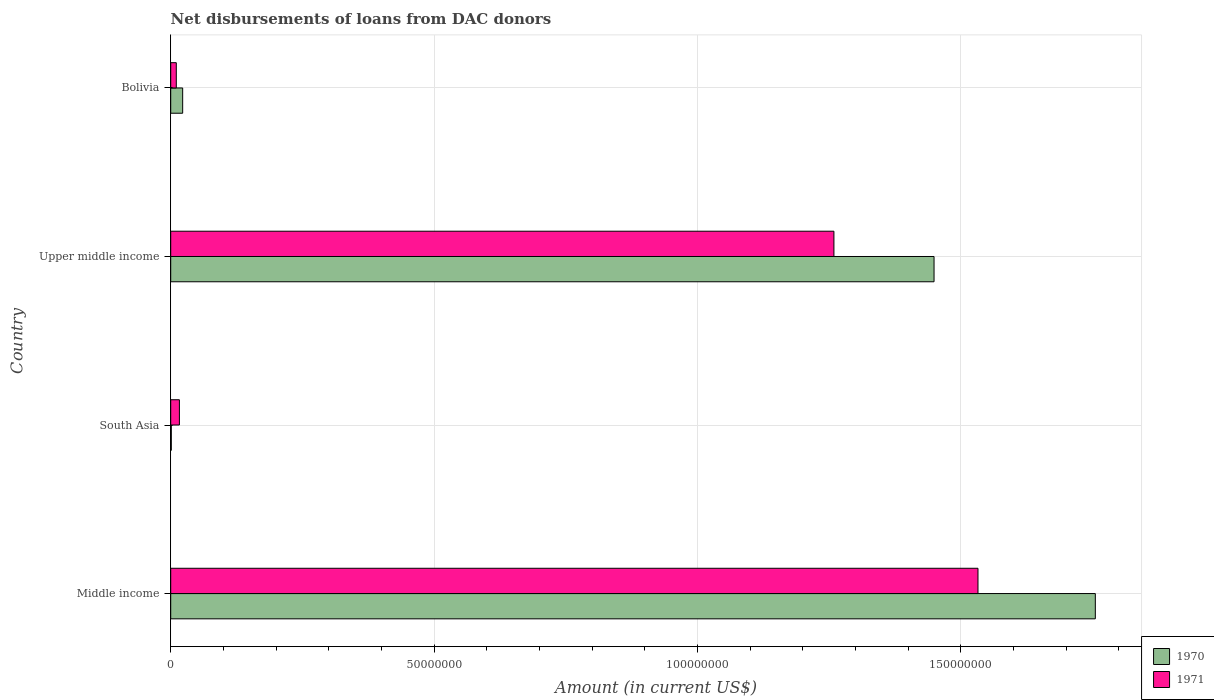How many different coloured bars are there?
Your response must be concise. 2. Are the number of bars per tick equal to the number of legend labels?
Your response must be concise. Yes. Are the number of bars on each tick of the Y-axis equal?
Your answer should be very brief. Yes. What is the label of the 1st group of bars from the top?
Ensure brevity in your answer.  Bolivia. What is the amount of loans disbursed in 1970 in South Asia?
Your answer should be compact. 1.09e+05. Across all countries, what is the maximum amount of loans disbursed in 1970?
Your answer should be compact. 1.76e+08. Across all countries, what is the minimum amount of loans disbursed in 1971?
Give a very brief answer. 1.06e+06. In which country was the amount of loans disbursed in 1971 minimum?
Make the answer very short. Bolivia. What is the total amount of loans disbursed in 1970 in the graph?
Your answer should be compact. 3.23e+08. What is the difference between the amount of loans disbursed in 1970 in Middle income and that in Upper middle income?
Your answer should be compact. 3.06e+07. What is the difference between the amount of loans disbursed in 1971 in South Asia and the amount of loans disbursed in 1970 in Bolivia?
Make the answer very short. -6.20e+05. What is the average amount of loans disbursed in 1971 per country?
Make the answer very short. 7.05e+07. What is the difference between the amount of loans disbursed in 1971 and amount of loans disbursed in 1970 in South Asia?
Give a very brief answer. 1.54e+06. In how many countries, is the amount of loans disbursed in 1971 greater than 130000000 US$?
Give a very brief answer. 1. What is the ratio of the amount of loans disbursed in 1971 in Middle income to that in South Asia?
Offer a terse response. 92.89. What is the difference between the highest and the second highest amount of loans disbursed in 1971?
Make the answer very short. 2.74e+07. What is the difference between the highest and the lowest amount of loans disbursed in 1970?
Your answer should be compact. 1.75e+08. In how many countries, is the amount of loans disbursed in 1971 greater than the average amount of loans disbursed in 1971 taken over all countries?
Your answer should be very brief. 2. Are all the bars in the graph horizontal?
Make the answer very short. Yes. Are the values on the major ticks of X-axis written in scientific E-notation?
Ensure brevity in your answer.  No. Does the graph contain any zero values?
Provide a short and direct response. No. Where does the legend appear in the graph?
Your answer should be compact. Bottom right. What is the title of the graph?
Make the answer very short. Net disbursements of loans from DAC donors. What is the label or title of the X-axis?
Provide a succinct answer. Amount (in current US$). What is the Amount (in current US$) of 1970 in Middle income?
Your answer should be compact. 1.76e+08. What is the Amount (in current US$) of 1971 in Middle income?
Your response must be concise. 1.53e+08. What is the Amount (in current US$) in 1970 in South Asia?
Your response must be concise. 1.09e+05. What is the Amount (in current US$) in 1971 in South Asia?
Provide a succinct answer. 1.65e+06. What is the Amount (in current US$) in 1970 in Upper middle income?
Make the answer very short. 1.45e+08. What is the Amount (in current US$) of 1971 in Upper middle income?
Provide a succinct answer. 1.26e+08. What is the Amount (in current US$) in 1970 in Bolivia?
Give a very brief answer. 2.27e+06. What is the Amount (in current US$) in 1971 in Bolivia?
Your answer should be very brief. 1.06e+06. Across all countries, what is the maximum Amount (in current US$) of 1970?
Offer a terse response. 1.76e+08. Across all countries, what is the maximum Amount (in current US$) of 1971?
Provide a succinct answer. 1.53e+08. Across all countries, what is the minimum Amount (in current US$) in 1970?
Ensure brevity in your answer.  1.09e+05. Across all countries, what is the minimum Amount (in current US$) of 1971?
Provide a short and direct response. 1.06e+06. What is the total Amount (in current US$) in 1970 in the graph?
Give a very brief answer. 3.23e+08. What is the total Amount (in current US$) of 1971 in the graph?
Make the answer very short. 2.82e+08. What is the difference between the Amount (in current US$) in 1970 in Middle income and that in South Asia?
Give a very brief answer. 1.75e+08. What is the difference between the Amount (in current US$) in 1971 in Middle income and that in South Asia?
Your answer should be compact. 1.52e+08. What is the difference between the Amount (in current US$) in 1970 in Middle income and that in Upper middle income?
Provide a succinct answer. 3.06e+07. What is the difference between the Amount (in current US$) of 1971 in Middle income and that in Upper middle income?
Keep it short and to the point. 2.74e+07. What is the difference between the Amount (in current US$) in 1970 in Middle income and that in Bolivia?
Offer a very short reply. 1.73e+08. What is the difference between the Amount (in current US$) of 1971 in Middle income and that in Bolivia?
Your answer should be compact. 1.52e+08. What is the difference between the Amount (in current US$) of 1970 in South Asia and that in Upper middle income?
Your answer should be very brief. -1.45e+08. What is the difference between the Amount (in current US$) of 1971 in South Asia and that in Upper middle income?
Provide a succinct answer. -1.24e+08. What is the difference between the Amount (in current US$) in 1970 in South Asia and that in Bolivia?
Provide a short and direct response. -2.16e+06. What is the difference between the Amount (in current US$) of 1971 in South Asia and that in Bolivia?
Offer a terse response. 5.92e+05. What is the difference between the Amount (in current US$) of 1970 in Upper middle income and that in Bolivia?
Provide a short and direct response. 1.43e+08. What is the difference between the Amount (in current US$) in 1971 in Upper middle income and that in Bolivia?
Your answer should be compact. 1.25e+08. What is the difference between the Amount (in current US$) of 1970 in Middle income and the Amount (in current US$) of 1971 in South Asia?
Keep it short and to the point. 1.74e+08. What is the difference between the Amount (in current US$) of 1970 in Middle income and the Amount (in current US$) of 1971 in Upper middle income?
Provide a succinct answer. 4.96e+07. What is the difference between the Amount (in current US$) in 1970 in Middle income and the Amount (in current US$) in 1971 in Bolivia?
Your answer should be compact. 1.74e+08. What is the difference between the Amount (in current US$) in 1970 in South Asia and the Amount (in current US$) in 1971 in Upper middle income?
Your answer should be compact. -1.26e+08. What is the difference between the Amount (in current US$) in 1970 in South Asia and the Amount (in current US$) in 1971 in Bolivia?
Keep it short and to the point. -9.49e+05. What is the difference between the Amount (in current US$) of 1970 in Upper middle income and the Amount (in current US$) of 1971 in Bolivia?
Offer a very short reply. 1.44e+08. What is the average Amount (in current US$) of 1970 per country?
Offer a terse response. 8.07e+07. What is the average Amount (in current US$) of 1971 per country?
Your response must be concise. 7.05e+07. What is the difference between the Amount (in current US$) in 1970 and Amount (in current US$) in 1971 in Middle income?
Make the answer very short. 2.23e+07. What is the difference between the Amount (in current US$) of 1970 and Amount (in current US$) of 1971 in South Asia?
Your answer should be compact. -1.54e+06. What is the difference between the Amount (in current US$) of 1970 and Amount (in current US$) of 1971 in Upper middle income?
Provide a short and direct response. 1.90e+07. What is the difference between the Amount (in current US$) of 1970 and Amount (in current US$) of 1971 in Bolivia?
Provide a succinct answer. 1.21e+06. What is the ratio of the Amount (in current US$) of 1970 in Middle income to that in South Asia?
Your response must be concise. 1610.58. What is the ratio of the Amount (in current US$) in 1971 in Middle income to that in South Asia?
Provide a short and direct response. 92.89. What is the ratio of the Amount (in current US$) of 1970 in Middle income to that in Upper middle income?
Ensure brevity in your answer.  1.21. What is the ratio of the Amount (in current US$) of 1971 in Middle income to that in Upper middle income?
Make the answer very short. 1.22. What is the ratio of the Amount (in current US$) in 1970 in Middle income to that in Bolivia?
Give a very brief answer. 77.34. What is the ratio of the Amount (in current US$) in 1971 in Middle income to that in Bolivia?
Make the answer very short. 144.87. What is the ratio of the Amount (in current US$) in 1970 in South Asia to that in Upper middle income?
Make the answer very short. 0. What is the ratio of the Amount (in current US$) in 1971 in South Asia to that in Upper middle income?
Ensure brevity in your answer.  0.01. What is the ratio of the Amount (in current US$) in 1970 in South Asia to that in Bolivia?
Offer a very short reply. 0.05. What is the ratio of the Amount (in current US$) of 1971 in South Asia to that in Bolivia?
Make the answer very short. 1.56. What is the ratio of the Amount (in current US$) of 1970 in Upper middle income to that in Bolivia?
Make the answer very short. 63.85. What is the ratio of the Amount (in current US$) in 1971 in Upper middle income to that in Bolivia?
Keep it short and to the point. 119.02. What is the difference between the highest and the second highest Amount (in current US$) in 1970?
Your answer should be very brief. 3.06e+07. What is the difference between the highest and the second highest Amount (in current US$) of 1971?
Offer a very short reply. 2.74e+07. What is the difference between the highest and the lowest Amount (in current US$) of 1970?
Provide a short and direct response. 1.75e+08. What is the difference between the highest and the lowest Amount (in current US$) of 1971?
Ensure brevity in your answer.  1.52e+08. 